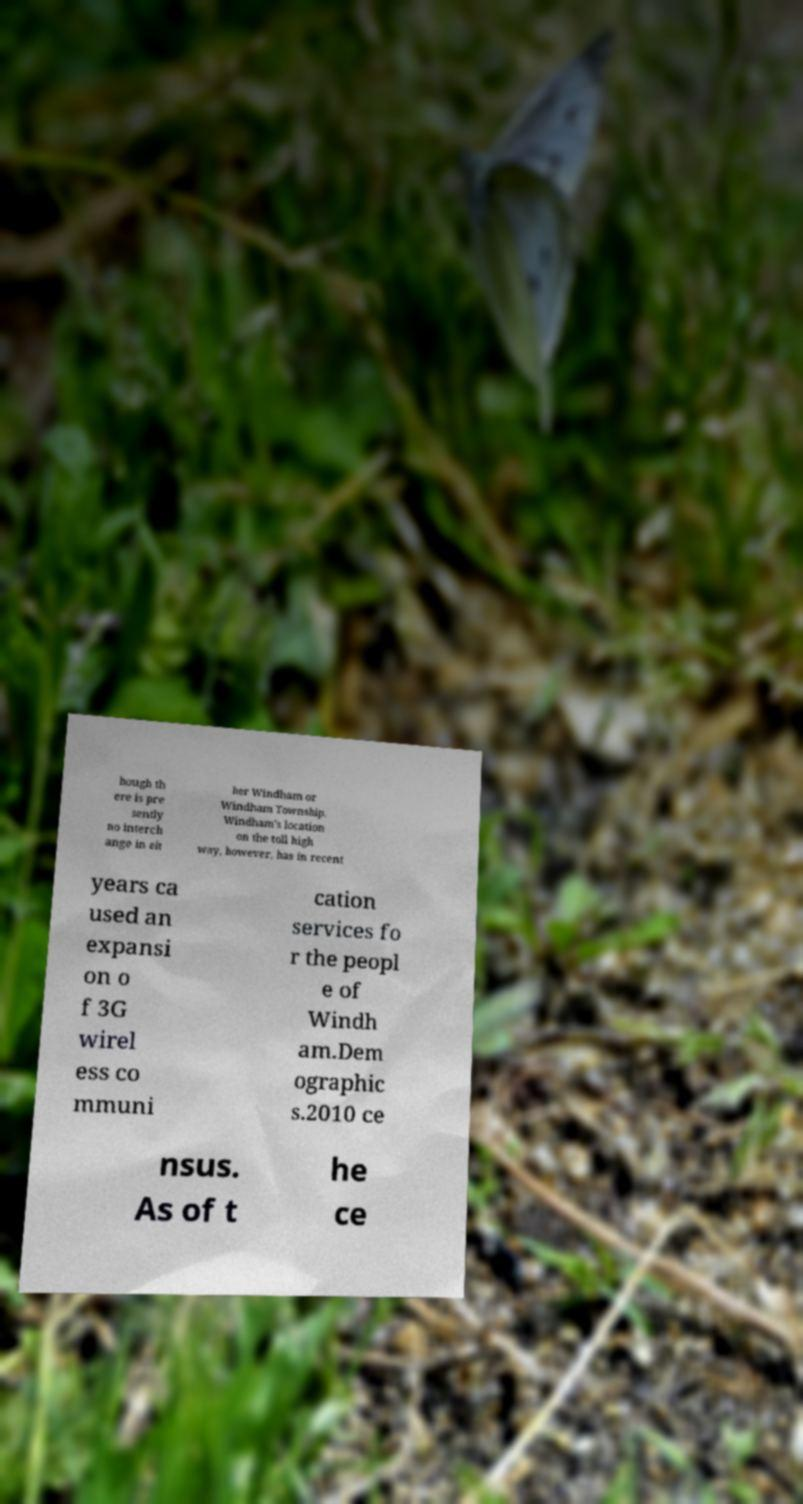There's text embedded in this image that I need extracted. Can you transcribe it verbatim? hough th ere is pre sently no interch ange in eit her Windham or Windham Township. Windham's location on the toll high way, however, has in recent years ca used an expansi on o f 3G wirel ess co mmuni cation services fo r the peopl e of Windh am.Dem ographic s.2010 ce nsus. As of t he ce 